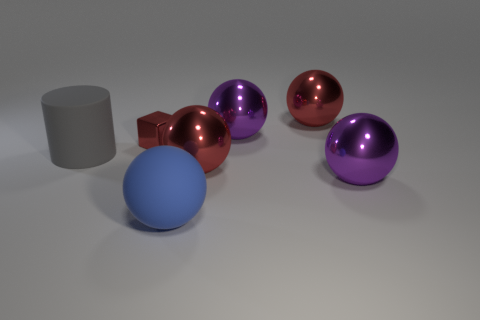Can you tell me the number of spheres in the image and their colors? Certainly! There are three spheres in the image. Two of them share a radiant, glossy purple appearance, while the third is a vibrant, glossy red, all reflecting their surroundings with a smooth, mirror-like finish. 